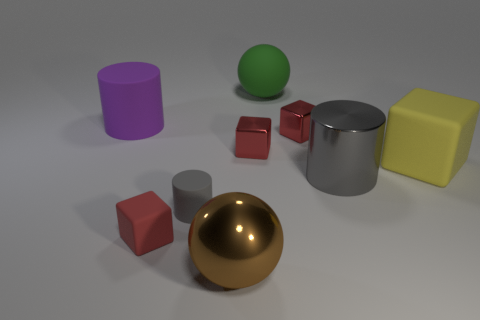How many gray cylinders must be subtracted to get 1 gray cylinders? 1 Subtract all yellow balls. How many red cubes are left? 3 Subtract all red blocks. Subtract all red spheres. How many blocks are left? 1 Add 1 small matte cylinders. How many objects exist? 10 Subtract all cubes. How many objects are left? 5 Subtract all big brown metallic balls. Subtract all large gray metal cylinders. How many objects are left? 7 Add 8 purple matte things. How many purple matte things are left? 9 Add 6 tiny red objects. How many tiny red objects exist? 9 Subtract 1 gray cylinders. How many objects are left? 8 